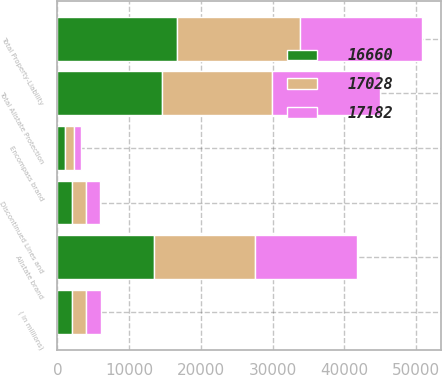Convert chart. <chart><loc_0><loc_0><loc_500><loc_500><stacked_bar_chart><ecel><fcel>( in millions)<fcel>Allstate brand<fcel>Encompass brand<fcel>Total Allstate Protection<fcel>Discontinued Lines and<fcel>Total Property-Liability<nl><fcel>17182<fcel>2009<fcel>14123<fcel>1027<fcel>15150<fcel>1878<fcel>17028<nl><fcel>17028<fcel>2008<fcel>14118<fcel>1133<fcel>15251<fcel>1931<fcel>17182<nl><fcel>16660<fcel>2007<fcel>13456<fcel>1129<fcel>14585<fcel>2075<fcel>16660<nl></chart> 